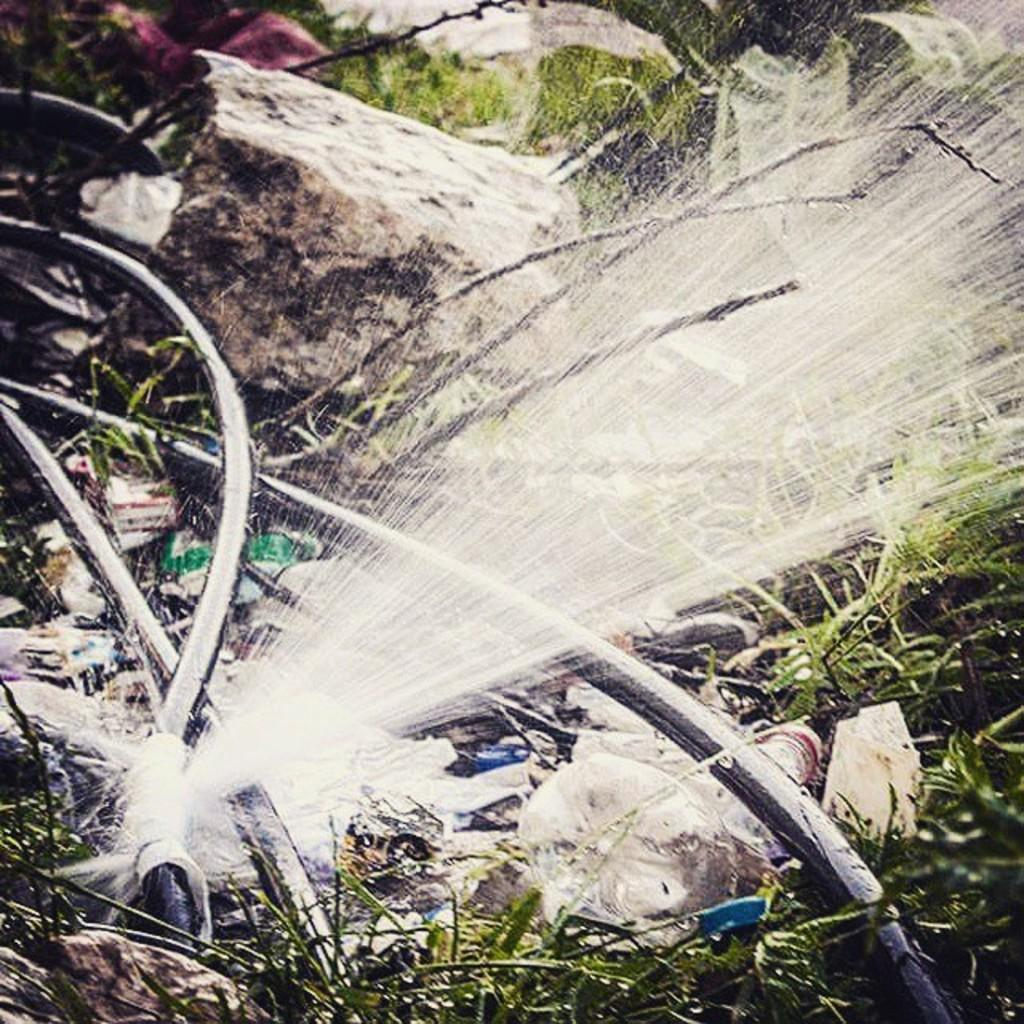What can be seen in the image related to plumbing? There are pipes in the image, and one of them is broken. What is the result of the broken pipe? Water is leaking from the broken pipe. What else is present in the image besides the pipes? There are plants, items, and a stone in the image. Can you describe the stone in the image? The stone appears blurry in the image. What type of mitten is being used to stop the water from leaking in the image? There is no mitten present in the image; it is a picture of pipes, water leaking, plants, items, and a blurry stone. 